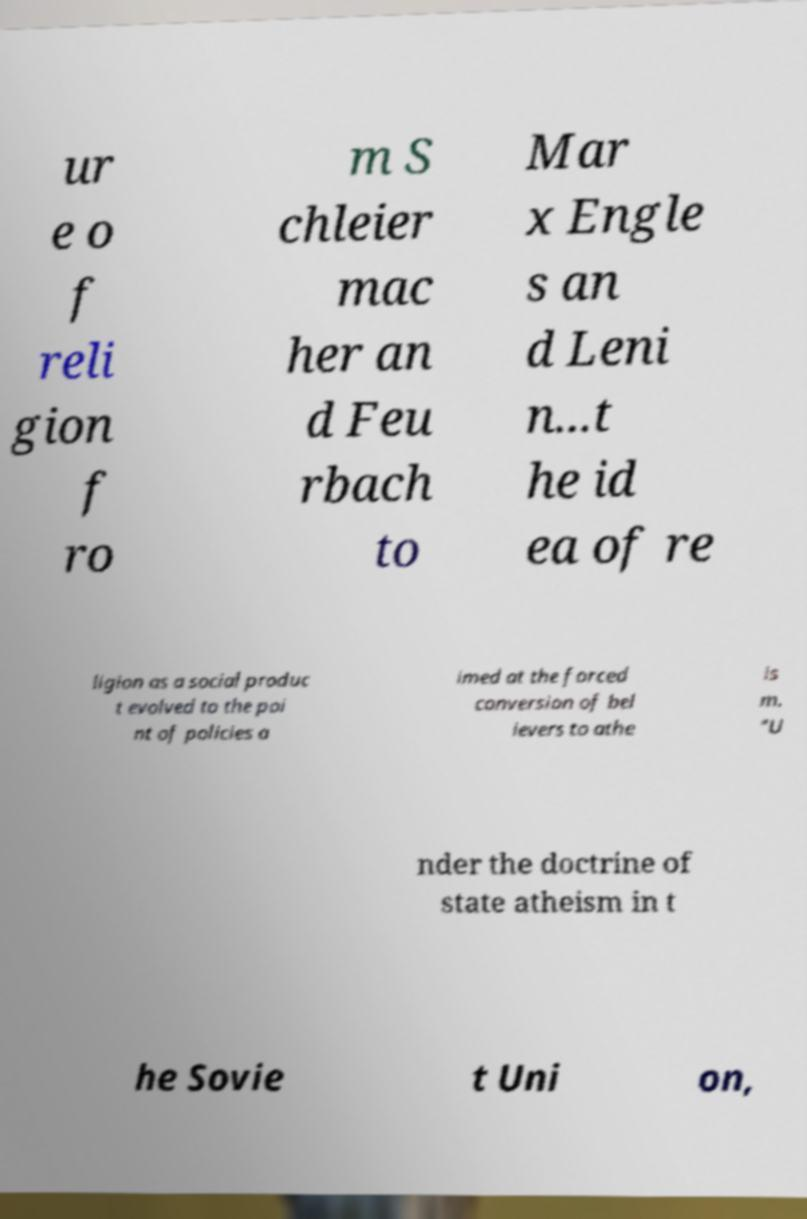I need the written content from this picture converted into text. Can you do that? ur e o f reli gion f ro m S chleier mac her an d Feu rbach to Mar x Engle s an d Leni n...t he id ea of re ligion as a social produc t evolved to the poi nt of policies a imed at the forced conversion of bel ievers to athe is m. "U nder the doctrine of state atheism in t he Sovie t Uni on, 